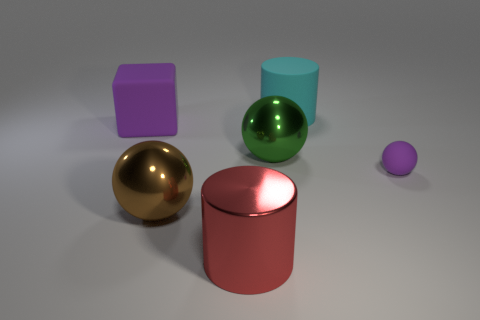What number of objects are large brown spheres or green shiny objects?
Your answer should be compact. 2. The cyan matte object that is the same shape as the red thing is what size?
Offer a terse response. Large. Is there any other thing that is the same size as the brown shiny object?
Your answer should be compact. Yes. What number of other things are the same color as the block?
Your answer should be very brief. 1. What number of blocks are small blue matte objects or large green things?
Offer a terse response. 0. There is a large shiny ball behind the purple object that is to the right of the big cyan matte object; what is its color?
Offer a very short reply. Green. What is the shape of the green object?
Ensure brevity in your answer.  Sphere. Does the cylinder that is behind the red metal object have the same size as the matte sphere?
Your response must be concise. No. Are there any large gray things made of the same material as the small thing?
Ensure brevity in your answer.  No. What number of things are either purple cubes in front of the large cyan object or large green objects?
Give a very brief answer. 2. 